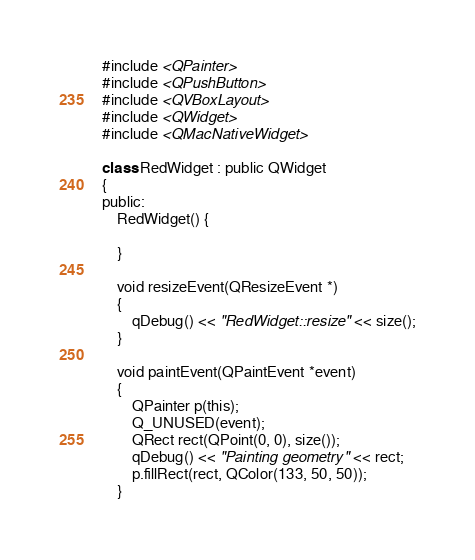<code> <loc_0><loc_0><loc_500><loc_500><_ObjectiveC_>#include <QPainter>
#include <QPushButton>
#include <QVBoxLayout>
#include <QWidget>
#include <QMacNativeWidget>

class RedWidget : public QWidget
{
public:
    RedWidget() {

    }

    void resizeEvent(QResizeEvent *)
    {
        qDebug() << "RedWidget::resize" << size();
    }

    void paintEvent(QPaintEvent *event)
    {
        QPainter p(this);
        Q_UNUSED(event);
        QRect rect(QPoint(0, 0), size());
        qDebug() << "Painting geometry" << rect;
        p.fillRect(rect, QColor(133, 50, 50));
    }</code> 